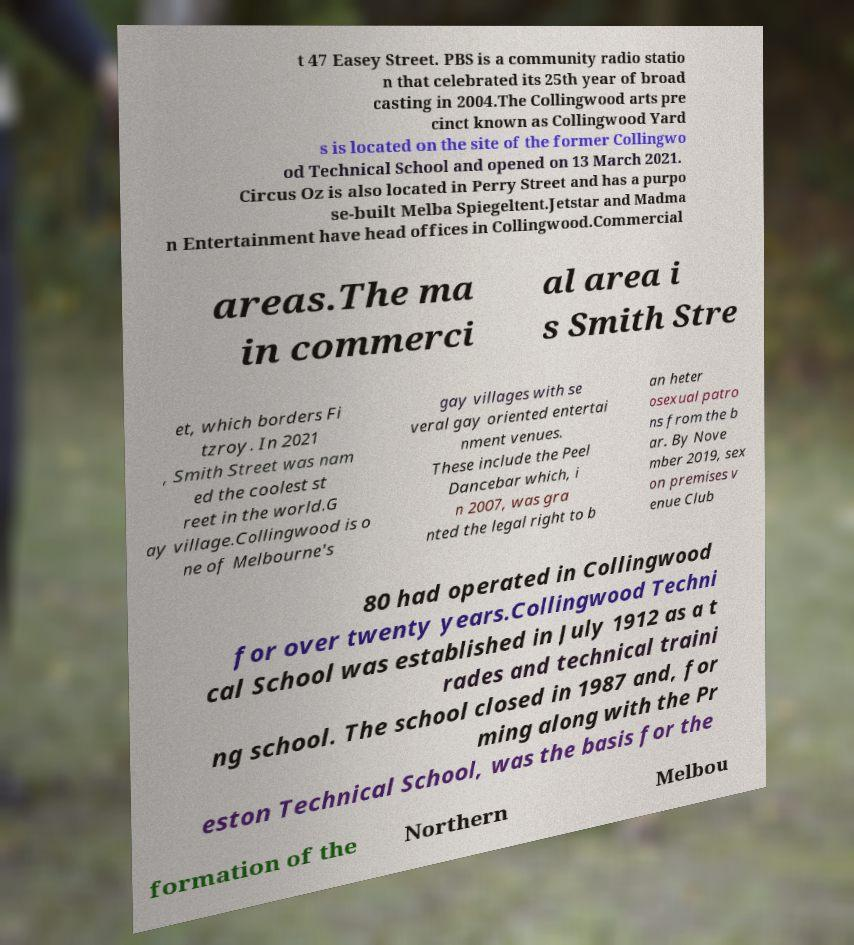For documentation purposes, I need the text within this image transcribed. Could you provide that? t 47 Easey Street. PBS is a community radio statio n that celebrated its 25th year of broad casting in 2004.The Collingwood arts pre cinct known as Collingwood Yard s is located on the site of the former Collingwo od Technical School and opened on 13 March 2021. Circus Oz is also located in Perry Street and has a purpo se-built Melba Spiegeltent.Jetstar and Madma n Entertainment have head offices in Collingwood.Commercial areas.The ma in commerci al area i s Smith Stre et, which borders Fi tzroy. In 2021 , Smith Street was nam ed the coolest st reet in the world.G ay village.Collingwood is o ne of Melbourne's gay villages with se veral gay oriented entertai nment venues. These include the Peel Dancebar which, i n 2007, was gra nted the legal right to b an heter osexual patro ns from the b ar. By Nove mber 2019, sex on premises v enue Club 80 had operated in Collingwood for over twenty years.Collingwood Techni cal School was established in July 1912 as a t rades and technical traini ng school. The school closed in 1987 and, for ming along with the Pr eston Technical School, was the basis for the formation of the Northern Melbou 